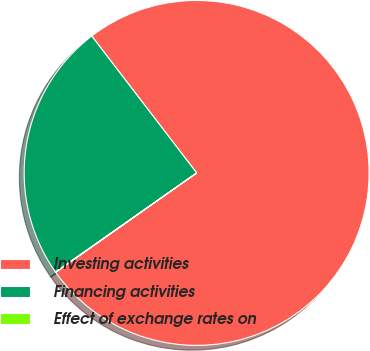Convert chart to OTSL. <chart><loc_0><loc_0><loc_500><loc_500><pie_chart><fcel>Investing activities<fcel>Financing activities<fcel>Effect of exchange rates on<nl><fcel>75.64%<fcel>24.34%<fcel>0.03%<nl></chart> 